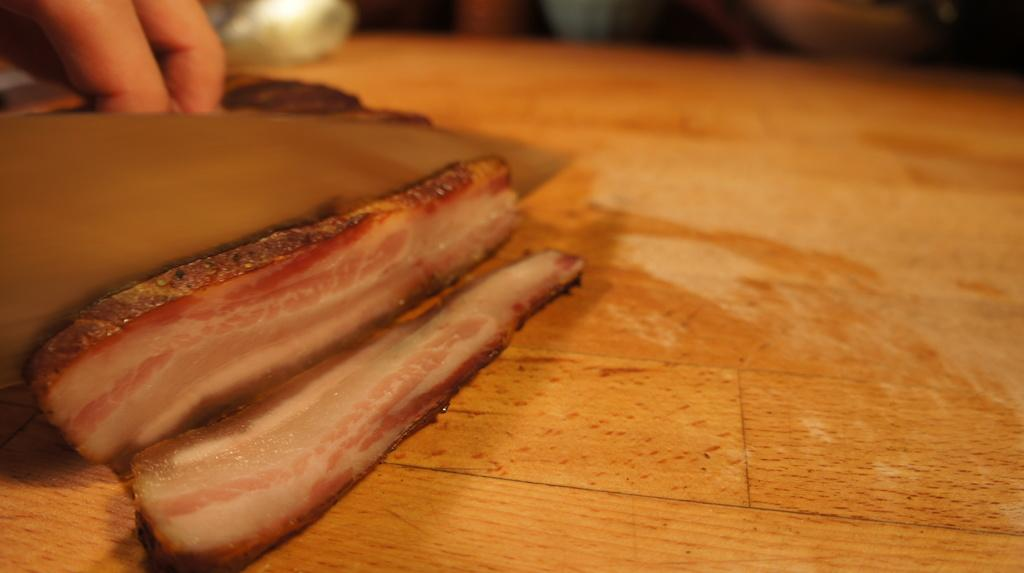What type of food is visible in the image? There is meat in the image. What is the meat placed on? The meat is on a wooden surface. Can you describe any other elements in the image? There is a person's hand in the top left corner of the image. What type of berry can be seen growing on the wooden surface in the image? There are no berries visible in the image; it features meat on a wooden surface and a person's hand. Is the meat hot in the image? The provided facts do not mention the temperature of the meat, so it cannot be determined from the image. 